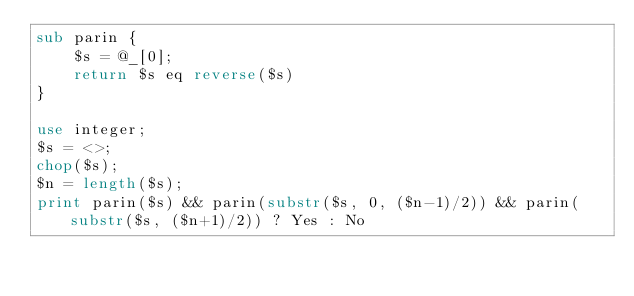<code> <loc_0><loc_0><loc_500><loc_500><_Perl_>sub parin {
	$s = @_[0];
	return $s eq reverse($s)
}

use integer;
$s = <>;
chop($s);
$n = length($s);
print parin($s) && parin(substr($s, 0, ($n-1)/2)) && parin(substr($s, ($n+1)/2)) ? Yes : No</code> 